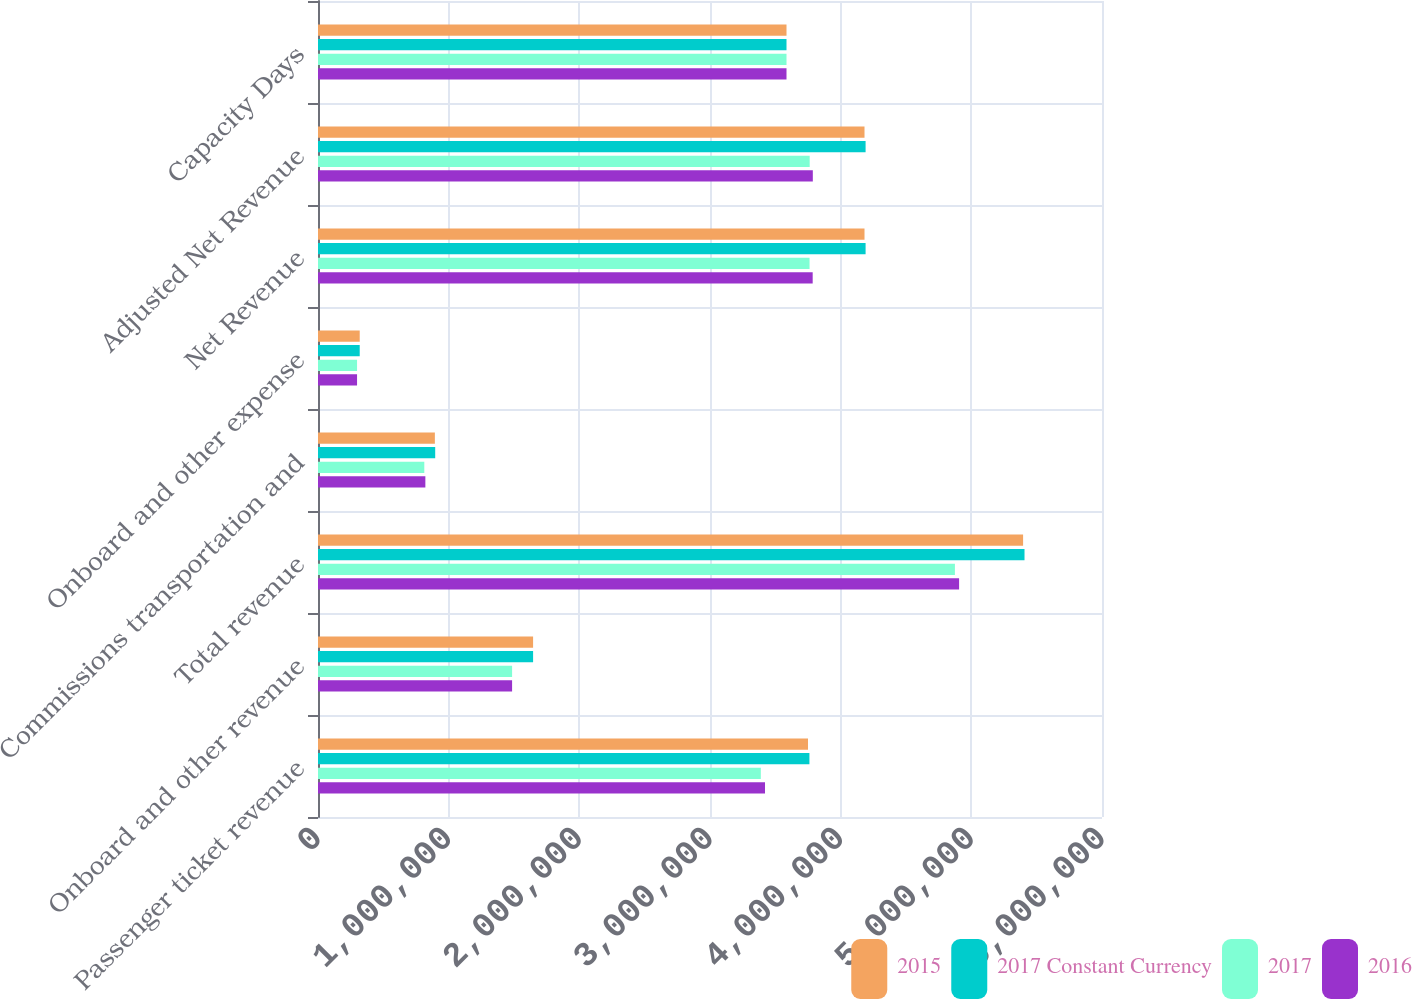Convert chart to OTSL. <chart><loc_0><loc_0><loc_500><loc_500><stacked_bar_chart><ecel><fcel>Passenger ticket revenue<fcel>Onboard and other revenue<fcel>Total revenue<fcel>Commissions transportation and<fcel>Onboard and other expense<fcel>Net Revenue<fcel>Adjusted Net Revenue<fcel>Capacity Days<nl><fcel>2015<fcel>3.75003e+06<fcel>1.64614e+06<fcel>5.39618e+06<fcel>894406<fcel>319293<fcel>4.18248e+06<fcel>4.18248e+06<fcel>3.58549e+06<nl><fcel>2017 Constant Currency<fcel>3.76089e+06<fcel>1.64614e+06<fcel>5.40703e+06<fcel>896985<fcel>319293<fcel>4.19075e+06<fcel>4.19075e+06<fcel>3.58549e+06<nl><fcel>2017<fcel>3.38895e+06<fcel>1.48539e+06<fcel>4.87434e+06<fcel>813559<fcel>298886<fcel>3.7619e+06<fcel>3.76295e+06<fcel>3.58549e+06<nl><fcel>2016<fcel>3.42096e+06<fcel>1.48539e+06<fcel>4.90634e+06<fcel>821608<fcel>298886<fcel>3.78585e+06<fcel>3.78691e+06<fcel>3.58549e+06<nl></chart> 